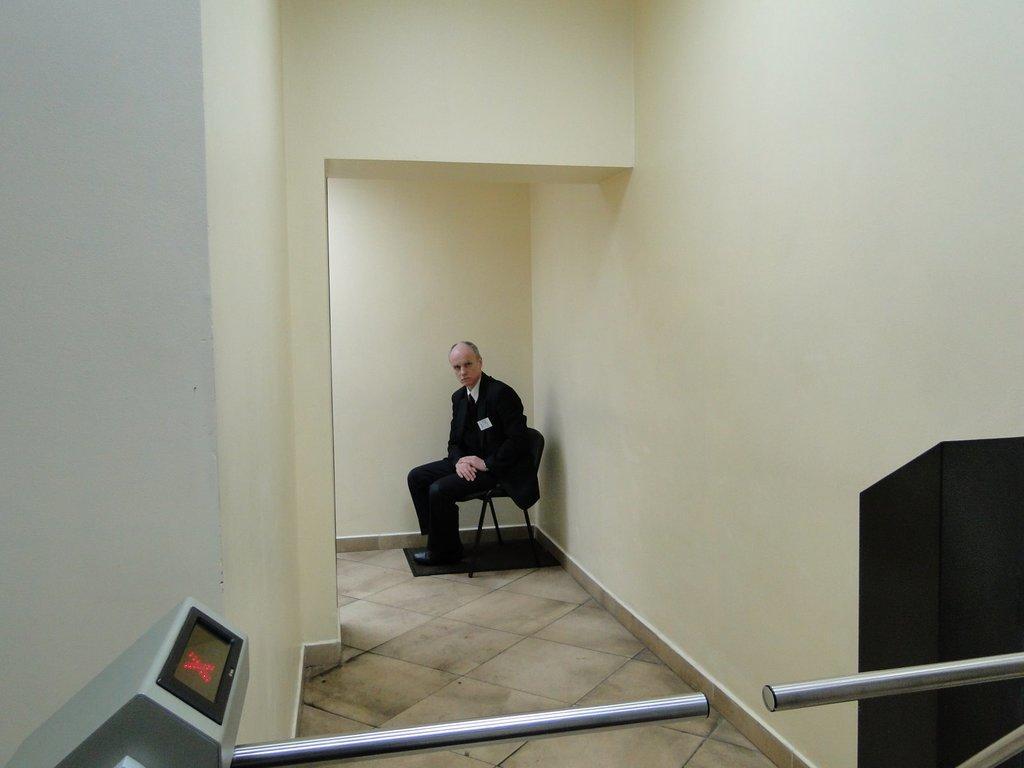How would you summarize this image in a sentence or two? At the bottom of the image we can see one machine, rods and one black color object. In the background there is a wall, mat and one person is sitting on the chair. 